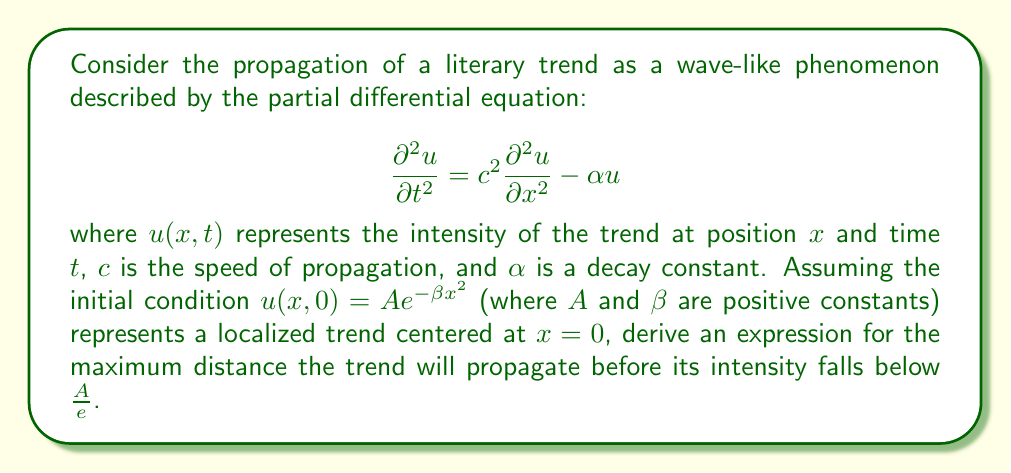What is the answer to this math problem? To solve this problem, we'll follow these steps:

1) First, we need to find the general solution to the wave equation with damping. The solution has the form:

   $$u(x,t) = f(x-ct)e^{-\frac{\alpha t}{2}} + g(x+ct)e^{-\frac{\alpha t}{2}}$$

   where $f$ and $g$ are arbitrary functions.

2) Given the initial condition $u(x,0) = Ae^{-\beta x^2}$, we can determine that:

   $$f(x) + g(x) = Ae^{-\beta x^2}$$

3) For simplicity, let's assume the wave propagates symmetrically, so $f(x) = g(x) = \frac{1}{2}Ae^{-\beta x^2}$.

4) Now, our solution becomes:

   $$u(x,t) = \frac{A}{2}e^{-\beta(x-ct)^2}e^{-\frac{\alpha t}{2}} + \frac{A}{2}e^{-\beta(x+ct)^2}e^{-\frac{\alpha t}{2}}$$

5) The maximum distance will occur when $x = ct$, i.e., at the wavefront. Substituting this into our equation:

   $$u(ct,t) = \frac{A}{2}e^{-\frac{\alpha t}{2}} + \frac{A}{2}e^{-4\beta c^2t^2}e^{-\frac{\alpha t}{2}}$$

6) We want to find when this equals $\frac{A}{e}$:

   $$\frac{A}{e} = \frac{A}{2}e^{-\frac{\alpha t}{2}} + \frac{A}{2}e^{-4\beta c^2t^2}e^{-\frac{\alpha t}{2}}$$

7) Simplifying:

   $$\frac{1}{e} = \frac{1}{2}e^{-\frac{\alpha t}{2}} + \frac{1}{2}e^{-4\beta c^2t^2}e^{-\frac{\alpha t}{2}}$$

8) This equation doesn't have a simple analytical solution, but we can approximate it. The second term will be much smaller than the first for large $t$, so we can ignore it:

   $$\frac{1}{e} \approx \frac{1}{2}e^{-\frac{\alpha t}{2}}$$

9) Solving for $t$:

   $$t \approx \frac{2}{\alpha} \ln(2)$$

10) The maximum distance is then:

    $$x_{max} = ct = \frac{2c}{\alpha} \ln(2)$$

This gives us the approximate maximum distance the trend will propagate before its intensity falls below $\frac{A}{e}$.
Answer: The maximum distance the literary trend will propagate before its intensity falls below $\frac{A}{e}$ is approximately:

$$x_{max} \approx \frac{2c}{\alpha} \ln(2)$$

where $c$ is the speed of propagation and $\alpha$ is the decay constant. 